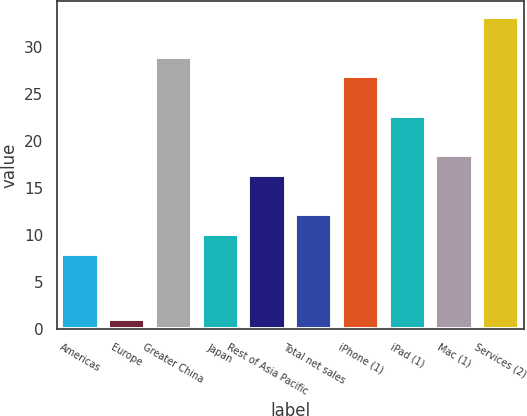<chart> <loc_0><loc_0><loc_500><loc_500><bar_chart><fcel>Americas<fcel>Europe<fcel>Greater China<fcel>Japan<fcel>Rest of Asia Pacific<fcel>Total net sales<fcel>iPhone (1)<fcel>iPad (1)<fcel>Mac (1)<fcel>Services (2)<nl><fcel>8<fcel>1<fcel>29<fcel>10.1<fcel>16.4<fcel>12.2<fcel>26.9<fcel>22.7<fcel>18.5<fcel>33.2<nl></chart> 